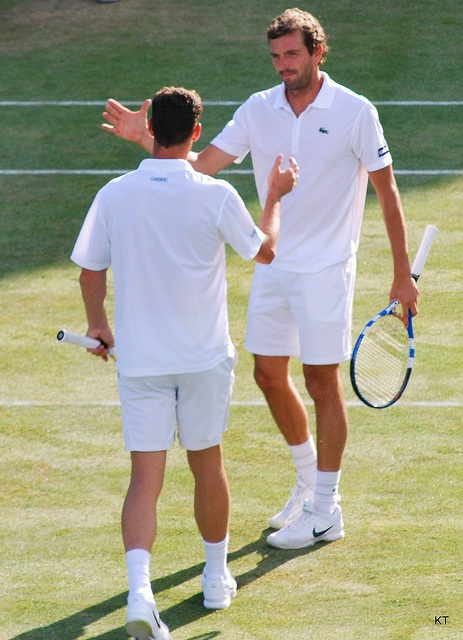Describe the objects in this image and their specific colors. I can see people in darkgreen, lavender, and brown tones, people in darkgreen, lavender, and brown tones, tennis racket in darkgreen, beige, lightgray, and tan tones, and tennis racket in darkgreen, darkgray, lightgray, and beige tones in this image. 